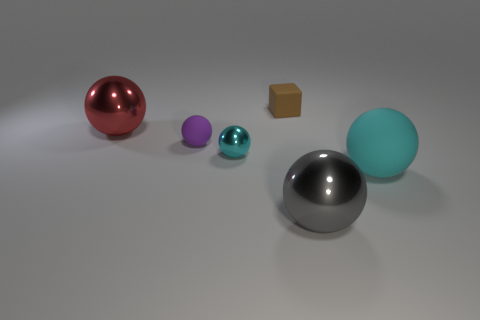How many balls are big cyan things or red shiny things?
Provide a succinct answer. 2. There is a tiny thing that is the same color as the big rubber sphere; what is its material?
Keep it short and to the point. Metal. Does the large rubber object have the same color as the tiny ball that is on the right side of the purple ball?
Offer a very short reply. Yes. What color is the small metal ball?
Make the answer very short. Cyan. What number of objects are either big shiny spheres or large yellow rubber cylinders?
Offer a very short reply. 2. There is a block that is the same size as the purple object; what is it made of?
Provide a short and direct response. Rubber. There is a thing that is behind the red object; what is its size?
Offer a very short reply. Small. What is the block made of?
Make the answer very short. Rubber. What number of things are spheres that are in front of the cyan metal object or things that are behind the large matte sphere?
Your answer should be very brief. 6. How many other things are the same color as the large matte thing?
Offer a terse response. 1. 